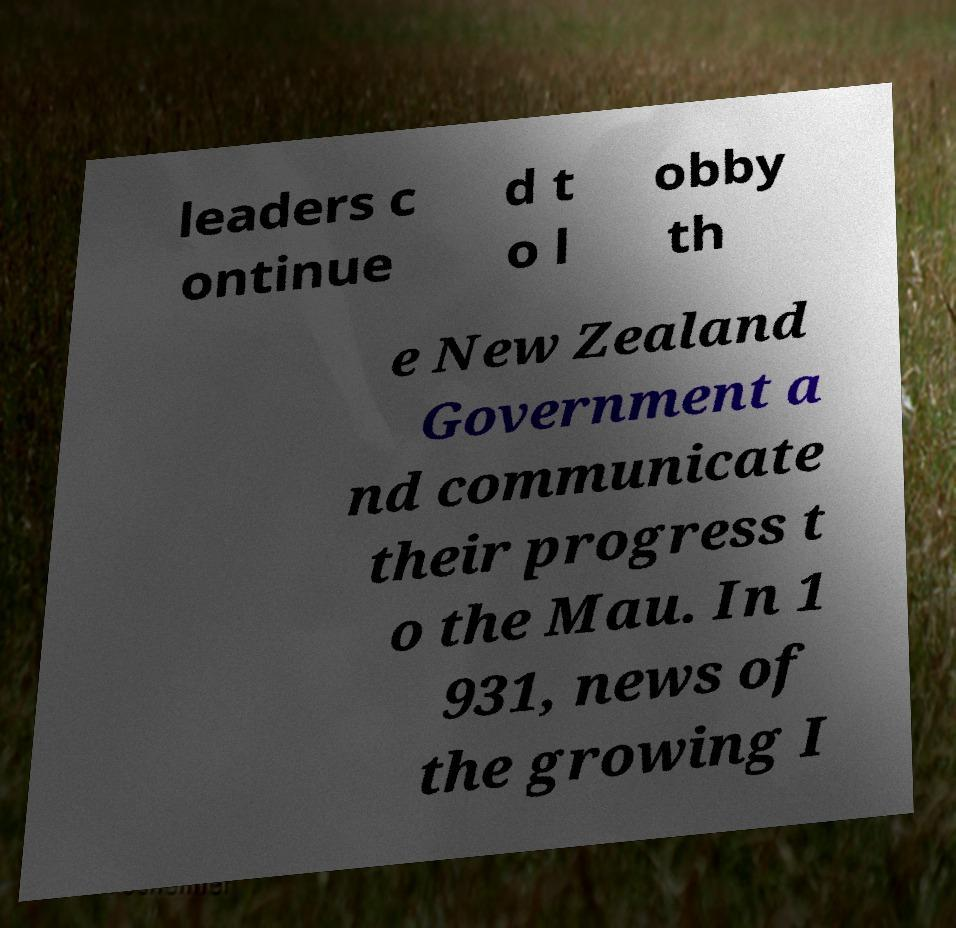There's text embedded in this image that I need extracted. Can you transcribe it verbatim? leaders c ontinue d t o l obby th e New Zealand Government a nd communicate their progress t o the Mau. In 1 931, news of the growing I 